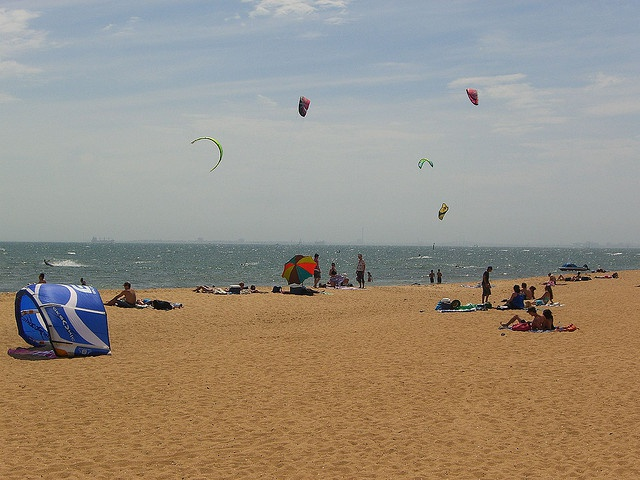Describe the objects in this image and their specific colors. I can see kite in darkgray, navy, black, and gray tones, people in darkgray, gray, black, and tan tones, umbrella in darkgray, black, olive, brown, and maroon tones, people in darkgray, black, maroon, and gray tones, and people in darkgray, black, maroon, and gray tones in this image. 